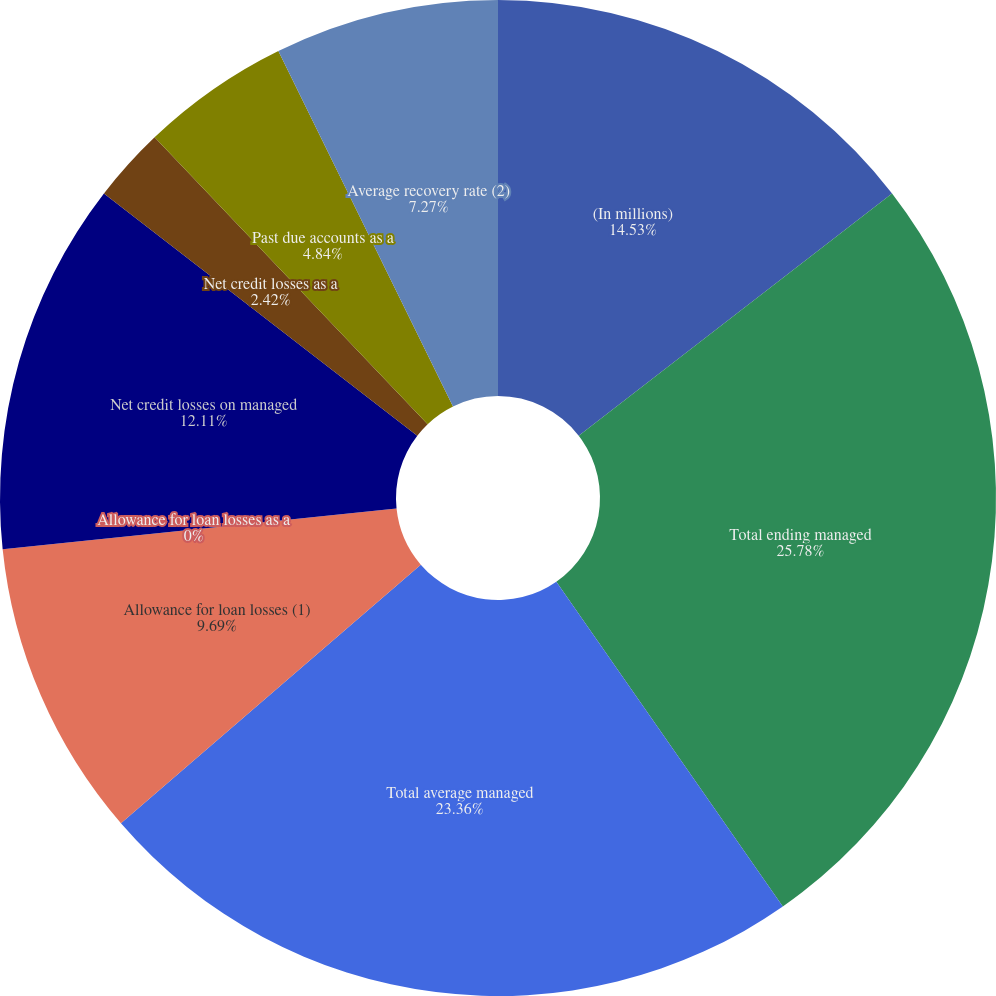Convert chart. <chart><loc_0><loc_0><loc_500><loc_500><pie_chart><fcel>(In millions)<fcel>Total ending managed<fcel>Total average managed<fcel>Allowance for loan losses (1)<fcel>Allowance for loan losses as a<fcel>Net credit losses on managed<fcel>Net credit losses as a<fcel>Past due accounts as a<fcel>Average recovery rate (2)<nl><fcel>14.53%<fcel>25.78%<fcel>23.36%<fcel>9.69%<fcel>0.0%<fcel>12.11%<fcel>2.42%<fcel>4.84%<fcel>7.27%<nl></chart> 